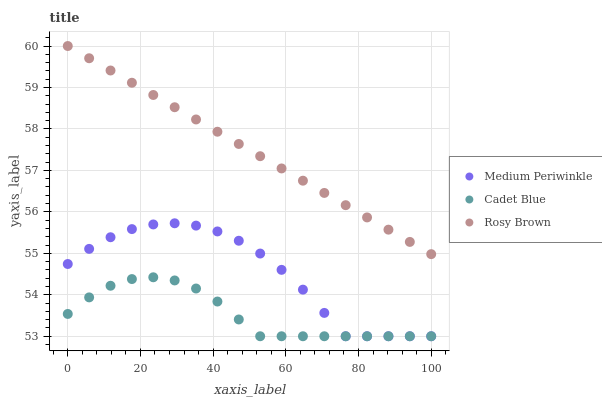Does Cadet Blue have the minimum area under the curve?
Answer yes or no. Yes. Does Rosy Brown have the maximum area under the curve?
Answer yes or no. Yes. Does Medium Periwinkle have the minimum area under the curve?
Answer yes or no. No. Does Medium Periwinkle have the maximum area under the curve?
Answer yes or no. No. Is Rosy Brown the smoothest?
Answer yes or no. Yes. Is Medium Periwinkle the roughest?
Answer yes or no. Yes. Is Cadet Blue the smoothest?
Answer yes or no. No. Is Cadet Blue the roughest?
Answer yes or no. No. Does Cadet Blue have the lowest value?
Answer yes or no. Yes. Does Rosy Brown have the highest value?
Answer yes or no. Yes. Does Medium Periwinkle have the highest value?
Answer yes or no. No. Is Cadet Blue less than Rosy Brown?
Answer yes or no. Yes. Is Rosy Brown greater than Cadet Blue?
Answer yes or no. Yes. Does Medium Periwinkle intersect Cadet Blue?
Answer yes or no. Yes. Is Medium Periwinkle less than Cadet Blue?
Answer yes or no. No. Is Medium Periwinkle greater than Cadet Blue?
Answer yes or no. No. Does Cadet Blue intersect Rosy Brown?
Answer yes or no. No. 